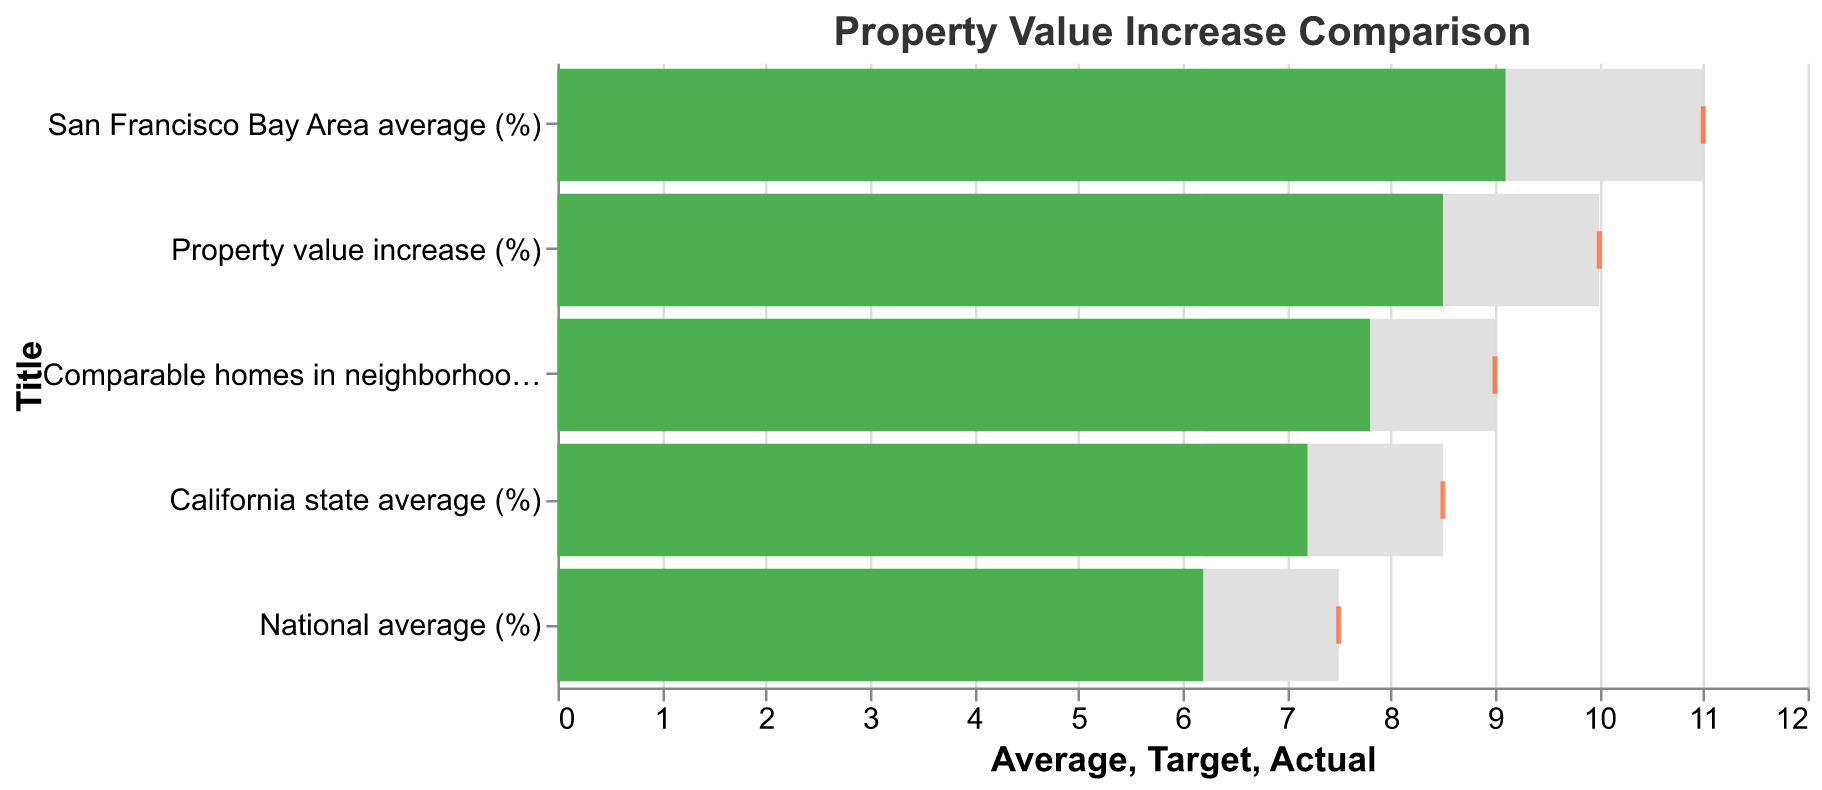What is the title of the chart? The title of the chart is directly displayed at the top and is labeled "Property Value Increase Comparison".
Answer: Property Value Increase Comparison What is the actual property value increase percentage for the San Francisco Bay Area? The actual value is represented by the green bar next to the "San Francisco Bay Area average (%)" category, which is labeled as 9.1%.
Answer: 9.1% How does your property's value increase compare to the national average? The actual property value increase for your property is 8.5%, while the national average is 6.2%. The comparison shows that your property value increase is higher by 2.3%.
Answer: 2.3% higher What is the target value for comparable homes in the neighborhood? The target value is denoted by an orange tick mark for the "Comparable homes in neighborhood (%)" category, which is labeled as 9%.
Answer: 9% What is the difference between the actual and average property value increase for California state? The actual value for California state is 7.2%, and the average is 6.2%. The difference is found by subtracting the average from the actual: 7.2% - 6.2% = 1%.
Answer: 1% Which category has the lowest target value? To find the lowest target value, we need to compare the target values of all categories. The national average (%) has the lowest target value, which is 7.5%.
Answer: National average (%) Is the actual property value increase of your home above or below the target value? The actual value for your property's increase is 8.5%, and the target value is 10%. Since 8.5% is less than 10%, it is below the target value.
Answer: Below By how much did the actual property value increase exceed the average for comparable homes in the neighborhood? The actual property value increase for comparable homes in the neighborhood is 7.8%, and the average is 6.2%. The difference is 7.8% - 6.2% = 1.6%.
Answer: 1.6% Which category had the actual value closest to its target value? To determine the closest actual to target value, calculate the difference for each category:
- Property value increase (%): 10% - 8.5% = 1.5%
- Comparable homes in neighborhood (%): 9% - 7.8% = 1.2%
- San Francisco Bay Area average (%): 11% - 9.1% = 1.9%
- California state average (%): 8.5% - 7.2% = 1.3%
- National average (%): 7.5% - 6.2% = 1.3%
The smallest difference is for comparable homes in the neighborhood, which is 1.2%.
Answer: Comparable homes in neighborhood (%) What is the color of the bars representing the actual property value increase percentages? The color of the bars representing the actual property value increase percentages are shown in green.
Answer: Green 